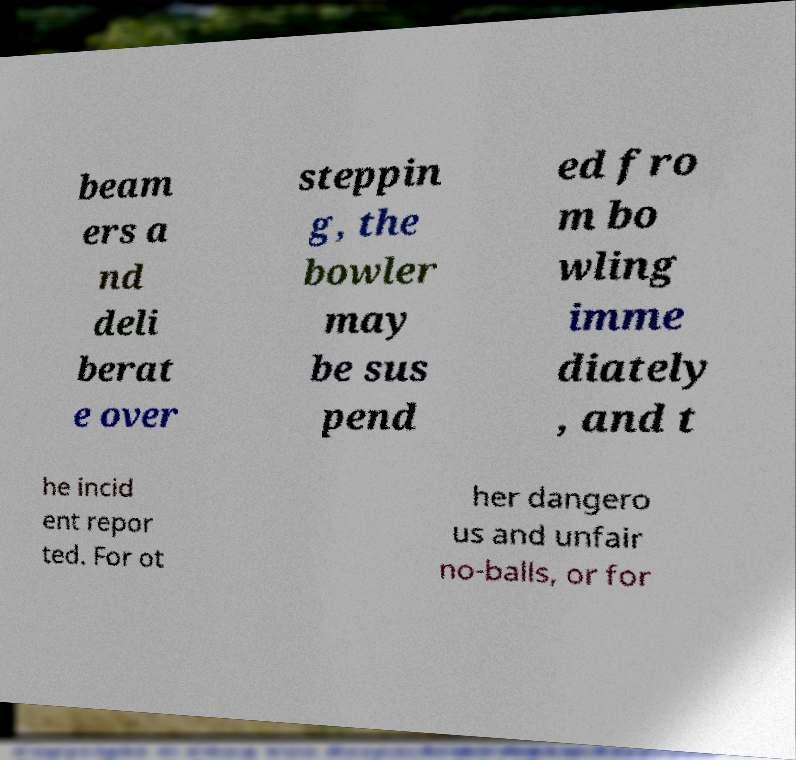Please read and relay the text visible in this image. What does it say? beam ers a nd deli berat e over steppin g, the bowler may be sus pend ed fro m bo wling imme diately , and t he incid ent repor ted. For ot her dangero us and unfair no-balls, or for 